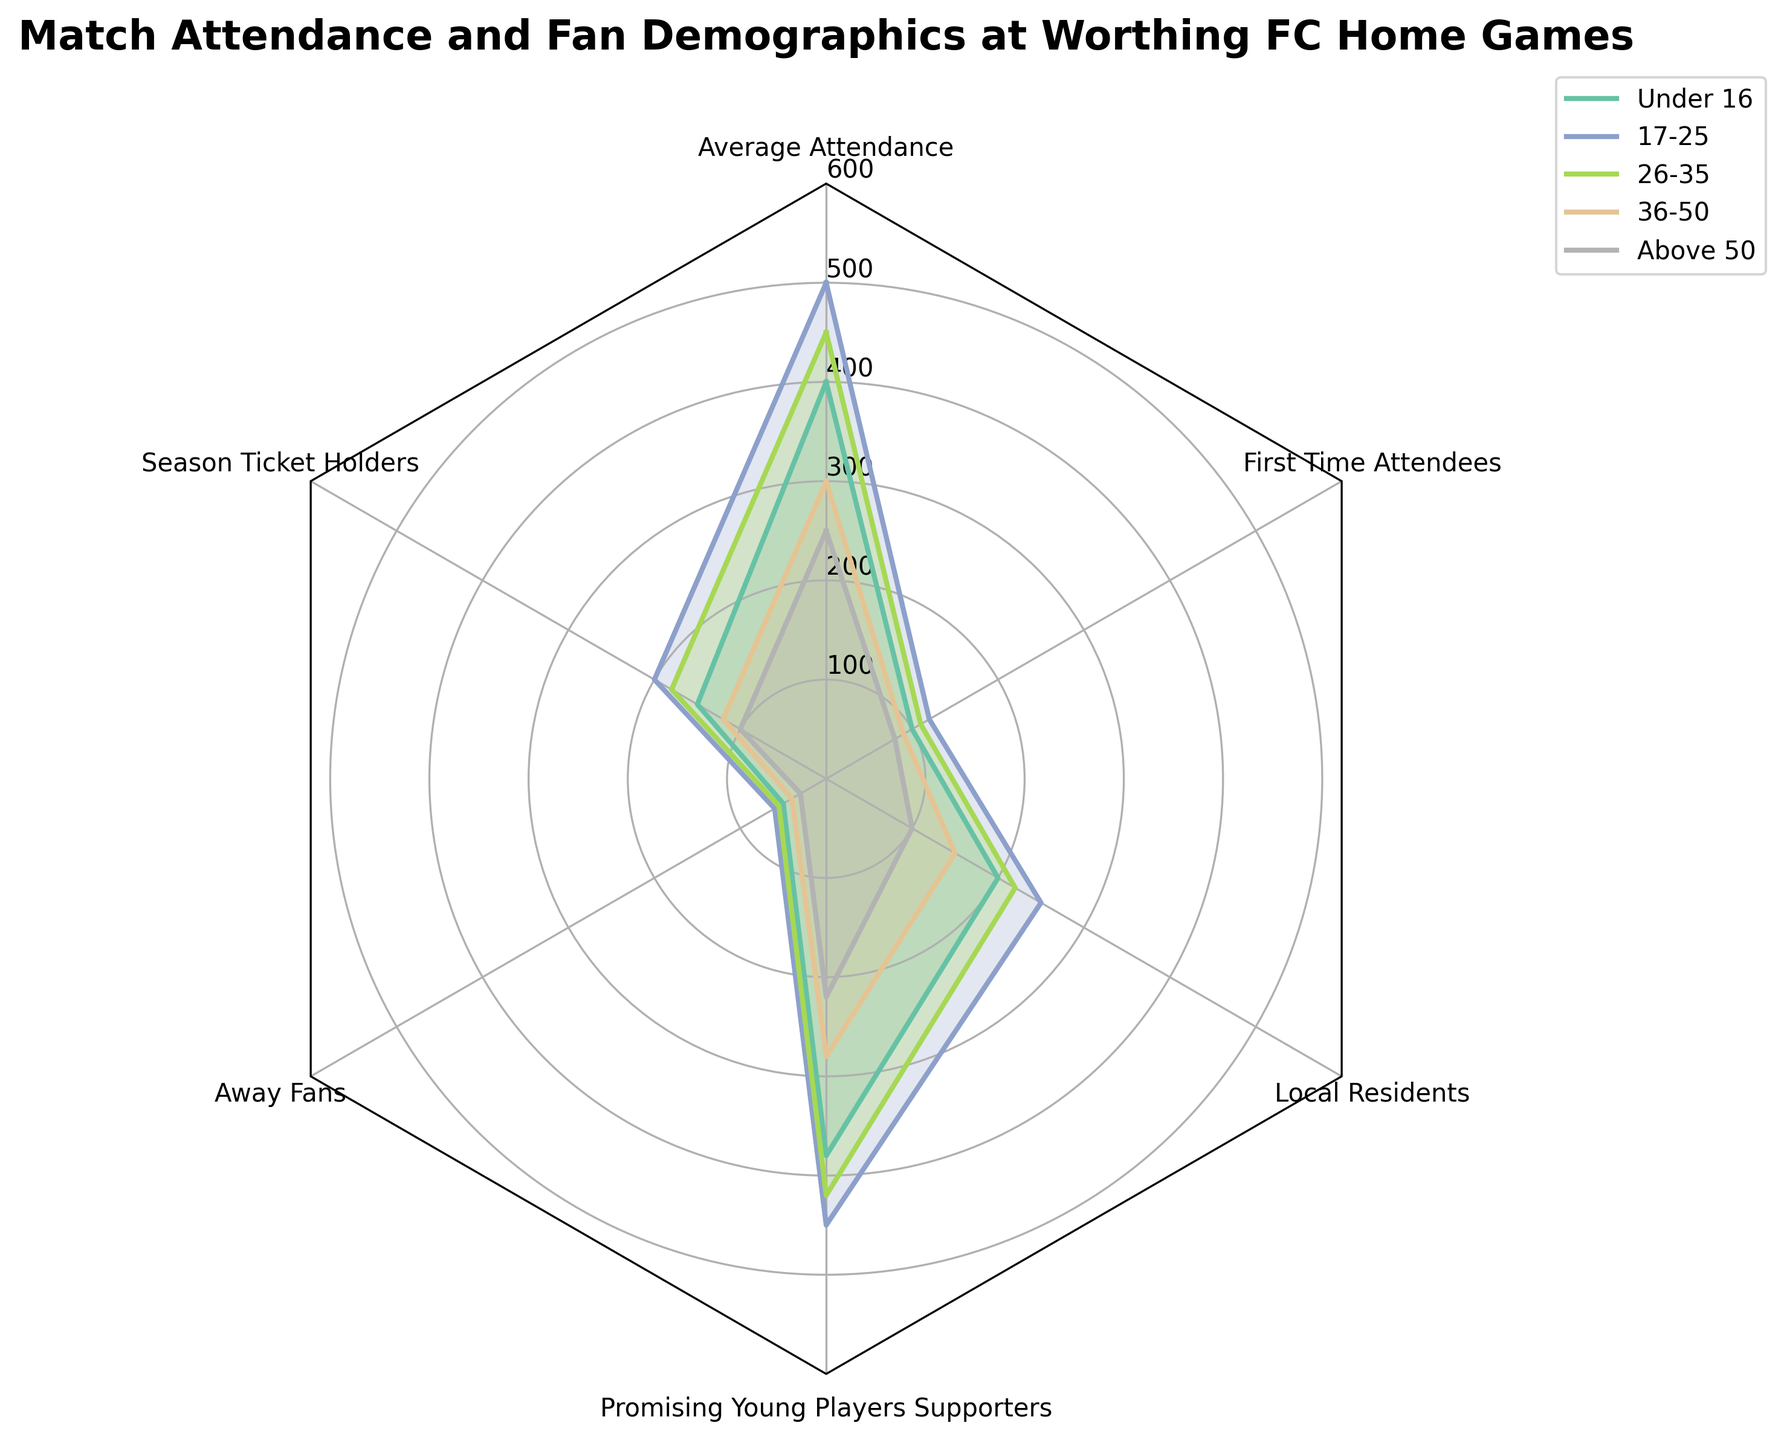What's the title of the radar chart? The title is clearly displayed at the top of the radar chart. It usually serves to give an overview of the chart's subject.
Answer: Match Attendance and Fan Demographics at Worthing FC Home Games How many different age groups are plotted in the radar chart? The radar chart shows different colors for each age group around the circular grid. By counting the legend entries, we can determine the number.
Answer: Five Which age group has the highest average attendance at Worthing FC home games? Examine the radar plot to see which age group's line extends the farthest out for the "Average Attendance" category. Look for the maximum data point.
Answer: 17-25 How many categories are shown in the radar chart? The categories are evenly spaced around the radar chart. By counting the distinct label points, you can determine the number of categories.
Answer: Six Are there more promising young players supporters or away fans among the 26-35 age group? Compare the lengths of the plotted points for "Promising Young Players Supporters" and "Away Fans" under the 26-35 age group by looking at their corresponding positions.
Answer: Promising Young Players Supporters What is the difference in the number of local residents and first-time attendees in the Under 16 age group? Subtract the number of first-time attendees from the number of local residents for the Under 16 age group, as indicated by the respective points on the chart.
Answer: 100 Which age group shows the highest support for promising young players? Find the age group with the largest value for "Promising Young Players Supporters". This can be identified by observing which line reaches the furthest for that category.
Answer: 17-25 In the 36-50 age group, is the number of season ticket holders more than the number of average attendees? Compare the respective lengths of the plotted points for "Season Ticket Holders" and "Average Attendance" under the 36-50 age group to determine if the former is greater than the latter.
Answer: No Which age group has the lowest local residents? Observe the values for each age group in the "Local Residents" category and identify the smallest one.
Answer: Above 50 In the 17-25 age group, calculate the difference between the number of season ticket holders and away fans. Subtract the number of "Away Fans" from "Season Ticket Holders" in the 17-25 age group. Use the corresponding values on the radar plot.
Answer: 140 